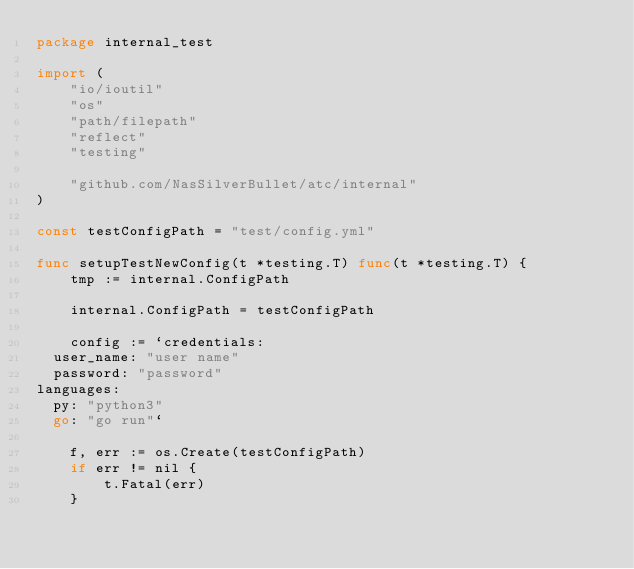Convert code to text. <code><loc_0><loc_0><loc_500><loc_500><_Go_>package internal_test

import (
	"io/ioutil"
	"os"
	"path/filepath"
	"reflect"
	"testing"

	"github.com/NasSilverBullet/atc/internal"
)

const testConfigPath = "test/config.yml"

func setupTestNewConfig(t *testing.T) func(t *testing.T) {
	tmp := internal.ConfigPath

	internal.ConfigPath = testConfigPath

	config := `credentials:
  user_name: "user name"
  password: "password"
languages:
  py: "python3"
  go: "go run"`

	f, err := os.Create(testConfigPath)
	if err != nil {
		t.Fatal(err)
	}</code> 